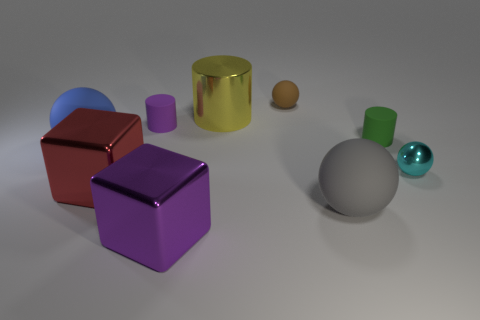There is a brown rubber thing that is behind the cyan object; is it the same size as the rubber sphere that is in front of the large blue rubber ball?
Give a very brief answer. No. The red cube that is made of the same material as the purple block is what size?
Your answer should be compact. Large. What is the color of the shiny thing that is to the right of the small rubber cylinder to the right of the matte cylinder that is on the left side of the big gray thing?
Your response must be concise. Cyan. Does the rubber cylinder that is left of the small green object have the same color as the big metallic object that is in front of the big gray rubber sphere?
Your answer should be very brief. Yes. What is the shape of the gray object to the left of the metallic object on the right side of the brown matte object?
Ensure brevity in your answer.  Sphere. Is there a red rubber cylinder that has the same size as the shiny ball?
Your response must be concise. No. How many small purple rubber objects have the same shape as the yellow object?
Your answer should be compact. 1. Are there an equal number of balls that are behind the brown matte object and things that are to the right of the small green cylinder?
Make the answer very short. No. Are there any small red cylinders?
Your answer should be very brief. No. There is a rubber cylinder to the right of the matte ball behind the shiny thing that is behind the green matte cylinder; how big is it?
Ensure brevity in your answer.  Small. 